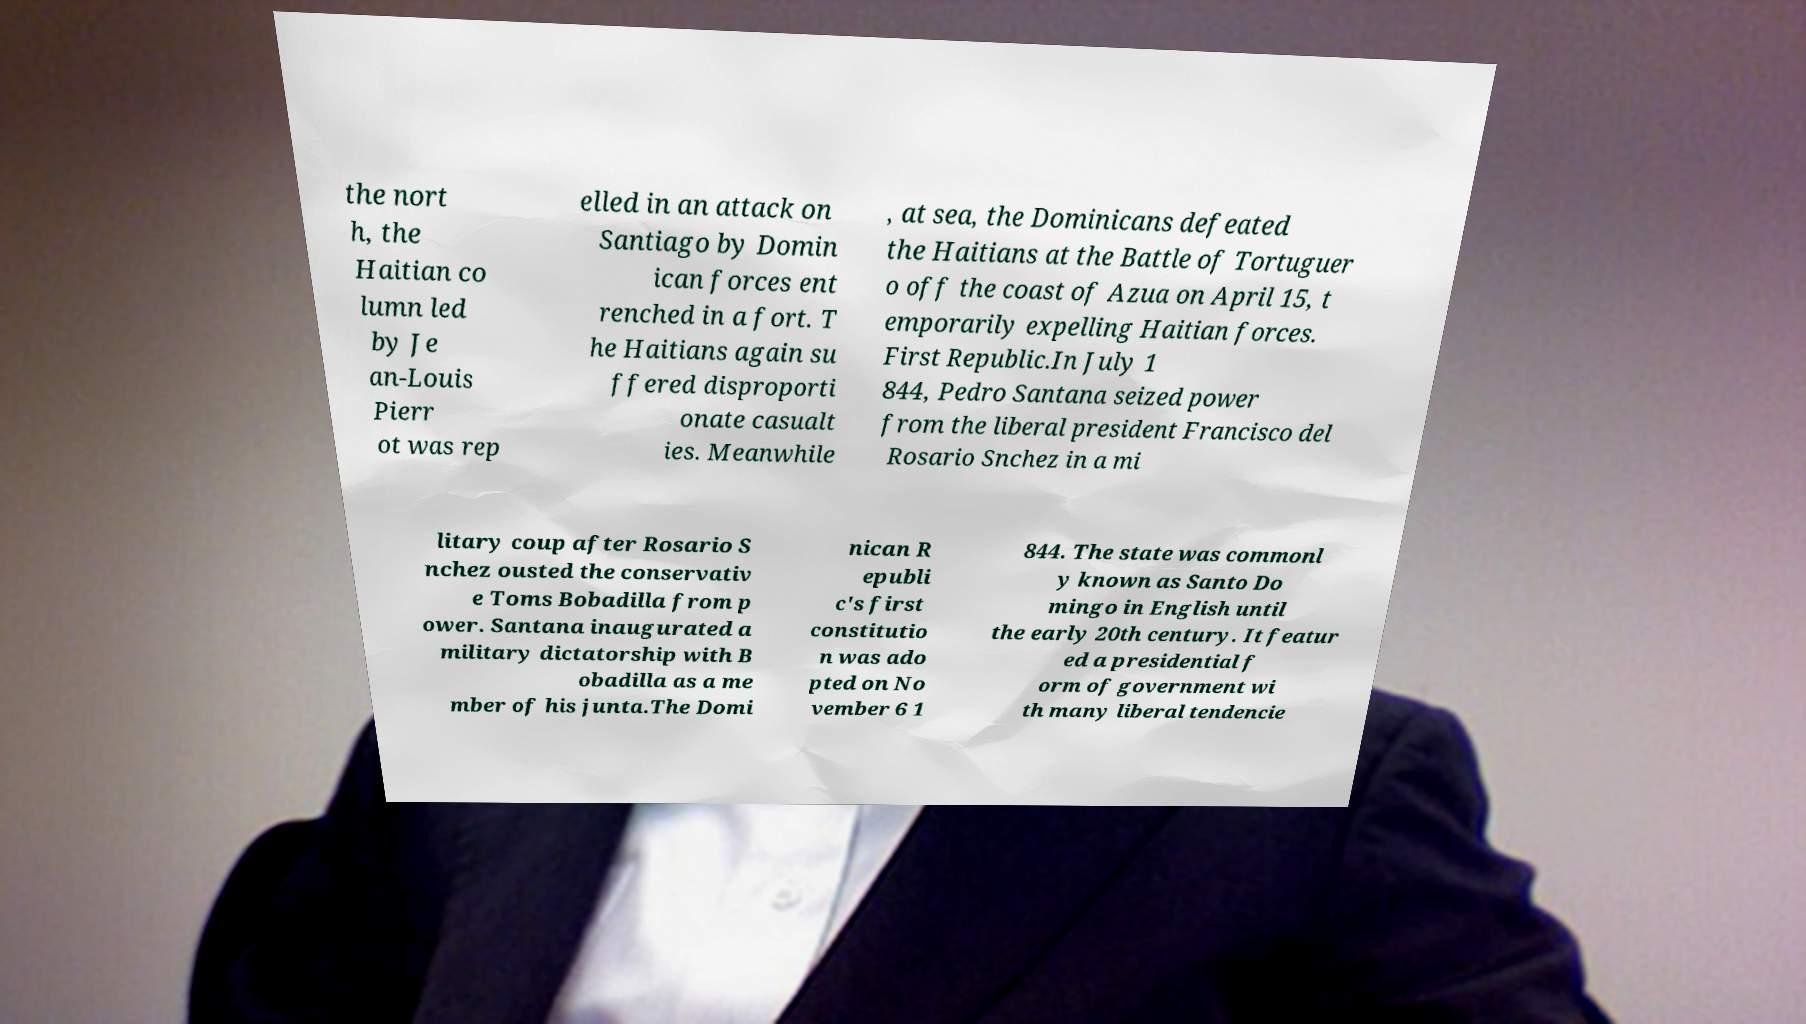I need the written content from this picture converted into text. Can you do that? the nort h, the Haitian co lumn led by Je an-Louis Pierr ot was rep elled in an attack on Santiago by Domin ican forces ent renched in a fort. T he Haitians again su ffered disproporti onate casualt ies. Meanwhile , at sea, the Dominicans defeated the Haitians at the Battle of Tortuguer o off the coast of Azua on April 15, t emporarily expelling Haitian forces. First Republic.In July 1 844, Pedro Santana seized power from the liberal president Francisco del Rosario Snchez in a mi litary coup after Rosario S nchez ousted the conservativ e Toms Bobadilla from p ower. Santana inaugurated a military dictatorship with B obadilla as a me mber of his junta.The Domi nican R epubli c's first constitutio n was ado pted on No vember 6 1 844. The state was commonl y known as Santo Do mingo in English until the early 20th century. It featur ed a presidential f orm of government wi th many liberal tendencie 